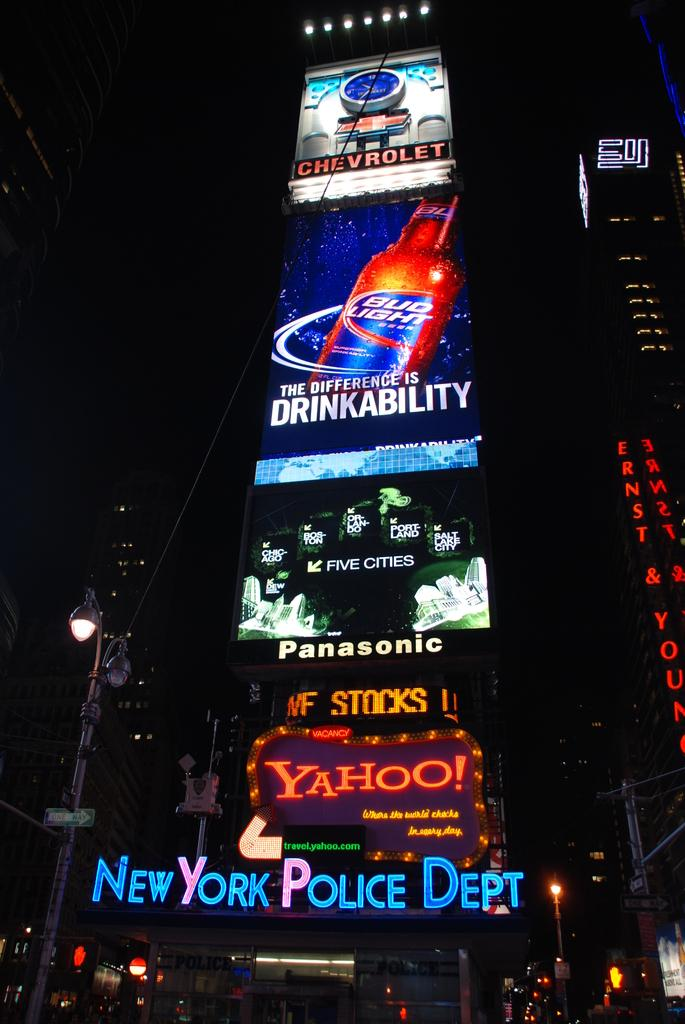Provide a one-sentence caption for the provided image. billboards from new york city featuring yahoo, bud light, chevrolet, and panasonic. 